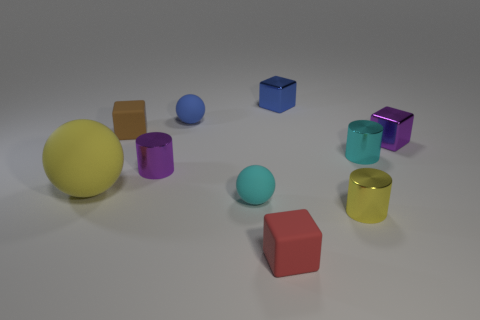Subtract all small blue spheres. How many spheres are left? 2 Subtract 1 cylinders. How many cylinders are left? 2 Subtract all red cubes. How many cubes are left? 3 Subtract all spheres. How many objects are left? 7 Subtract all brown blocks. Subtract all blue spheres. How many blocks are left? 3 Subtract all big matte cylinders. Subtract all small purple metal cylinders. How many objects are left? 9 Add 7 small blue metallic cubes. How many small blue metallic cubes are left? 8 Add 4 cubes. How many cubes exist? 8 Subtract 0 gray cubes. How many objects are left? 10 